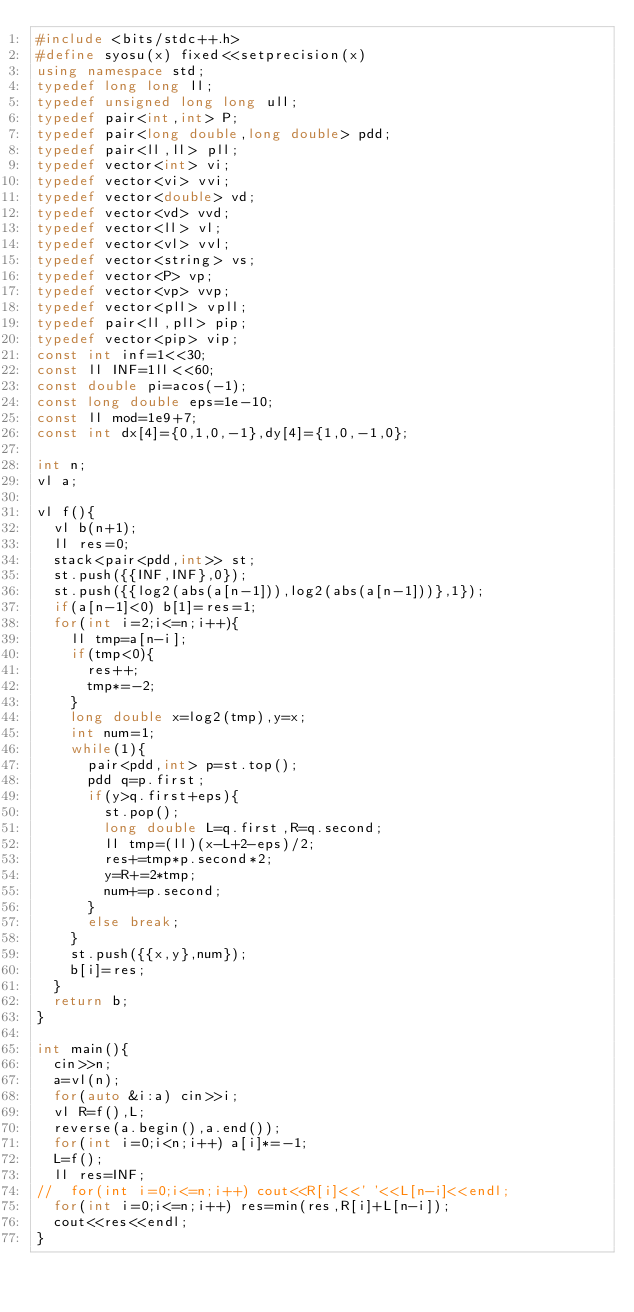<code> <loc_0><loc_0><loc_500><loc_500><_C++_>#include <bits/stdc++.h>
#define syosu(x) fixed<<setprecision(x)
using namespace std;
typedef long long ll;
typedef unsigned long long ull;
typedef pair<int,int> P;
typedef pair<long double,long double> pdd;
typedef pair<ll,ll> pll;
typedef vector<int> vi;
typedef vector<vi> vvi;
typedef vector<double> vd;
typedef vector<vd> vvd;
typedef vector<ll> vl;
typedef vector<vl> vvl;
typedef vector<string> vs;
typedef vector<P> vp;
typedef vector<vp> vvp;
typedef vector<pll> vpll;
typedef pair<ll,pll> pip;
typedef vector<pip> vip;
const int inf=1<<30;
const ll INF=1ll<<60;
const double pi=acos(-1);
const long double eps=1e-10;
const ll mod=1e9+7;
const int dx[4]={0,1,0,-1},dy[4]={1,0,-1,0};

int n;
vl a;

vl f(){
	vl b(n+1);
	ll res=0;
	stack<pair<pdd,int>> st;
	st.push({{INF,INF},0});
	st.push({{log2(abs(a[n-1])),log2(abs(a[n-1]))},1});
	if(a[n-1]<0) b[1]=res=1;
	for(int i=2;i<=n;i++){
		ll tmp=a[n-i];
		if(tmp<0){
			res++;
			tmp*=-2;
		}
		long double x=log2(tmp),y=x;
		int num=1;
		while(1){
			pair<pdd,int> p=st.top();
			pdd q=p.first;
			if(y>q.first+eps){
				st.pop();
				long double L=q.first,R=q.second;
				ll tmp=(ll)(x-L+2-eps)/2;
				res+=tmp*p.second*2;
				y=R+=2*tmp;
				num+=p.second;
			}
			else break;
		}
		st.push({{x,y},num});
		b[i]=res;
	}
	return b;
}

int main(){
	cin>>n;
	a=vl(n);
	for(auto &i:a) cin>>i;
	vl R=f(),L;
	reverse(a.begin(),a.end());
	for(int i=0;i<n;i++) a[i]*=-1;
	L=f();
	ll res=INF;
//	for(int i=0;i<=n;i++) cout<<R[i]<<' '<<L[n-i]<<endl;
	for(int i=0;i<=n;i++) res=min(res,R[i]+L[n-i]);
	cout<<res<<endl;
}</code> 